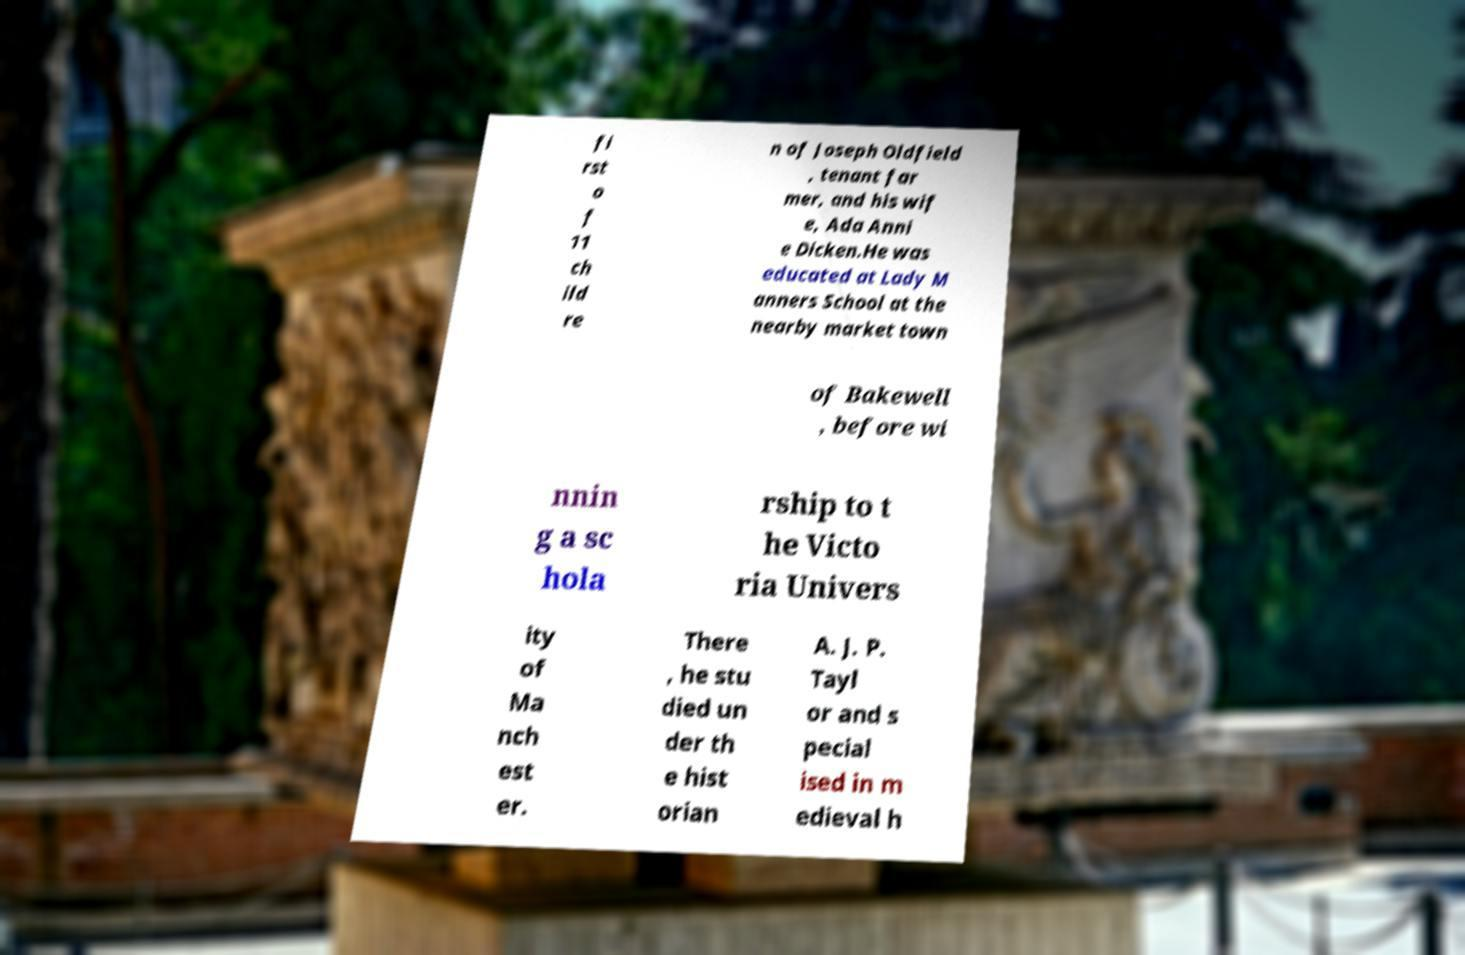I need the written content from this picture converted into text. Can you do that? fi rst o f 11 ch ild re n of Joseph Oldfield , tenant far mer, and his wif e, Ada Anni e Dicken.He was educated at Lady M anners School at the nearby market town of Bakewell , before wi nnin g a sc hola rship to t he Victo ria Univers ity of Ma nch est er. There , he stu died un der th e hist orian A. J. P. Tayl or and s pecial ised in m edieval h 